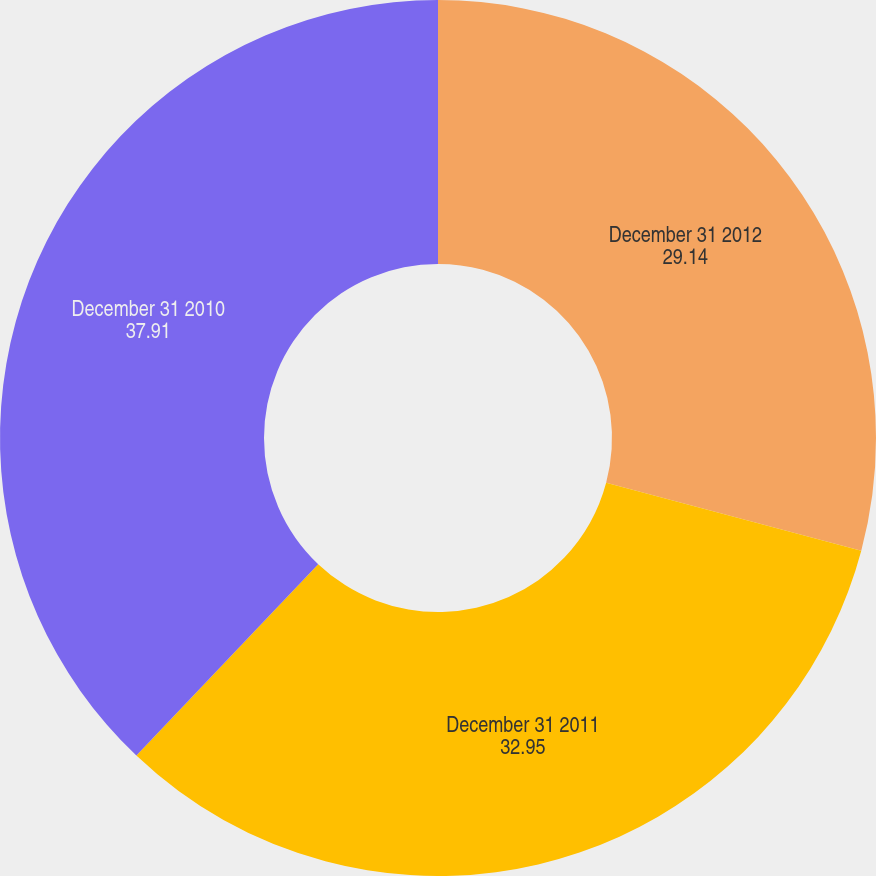<chart> <loc_0><loc_0><loc_500><loc_500><pie_chart><fcel>December 31 2012<fcel>December 31 2011<fcel>December 31 2010<nl><fcel>29.14%<fcel>32.95%<fcel>37.91%<nl></chart> 